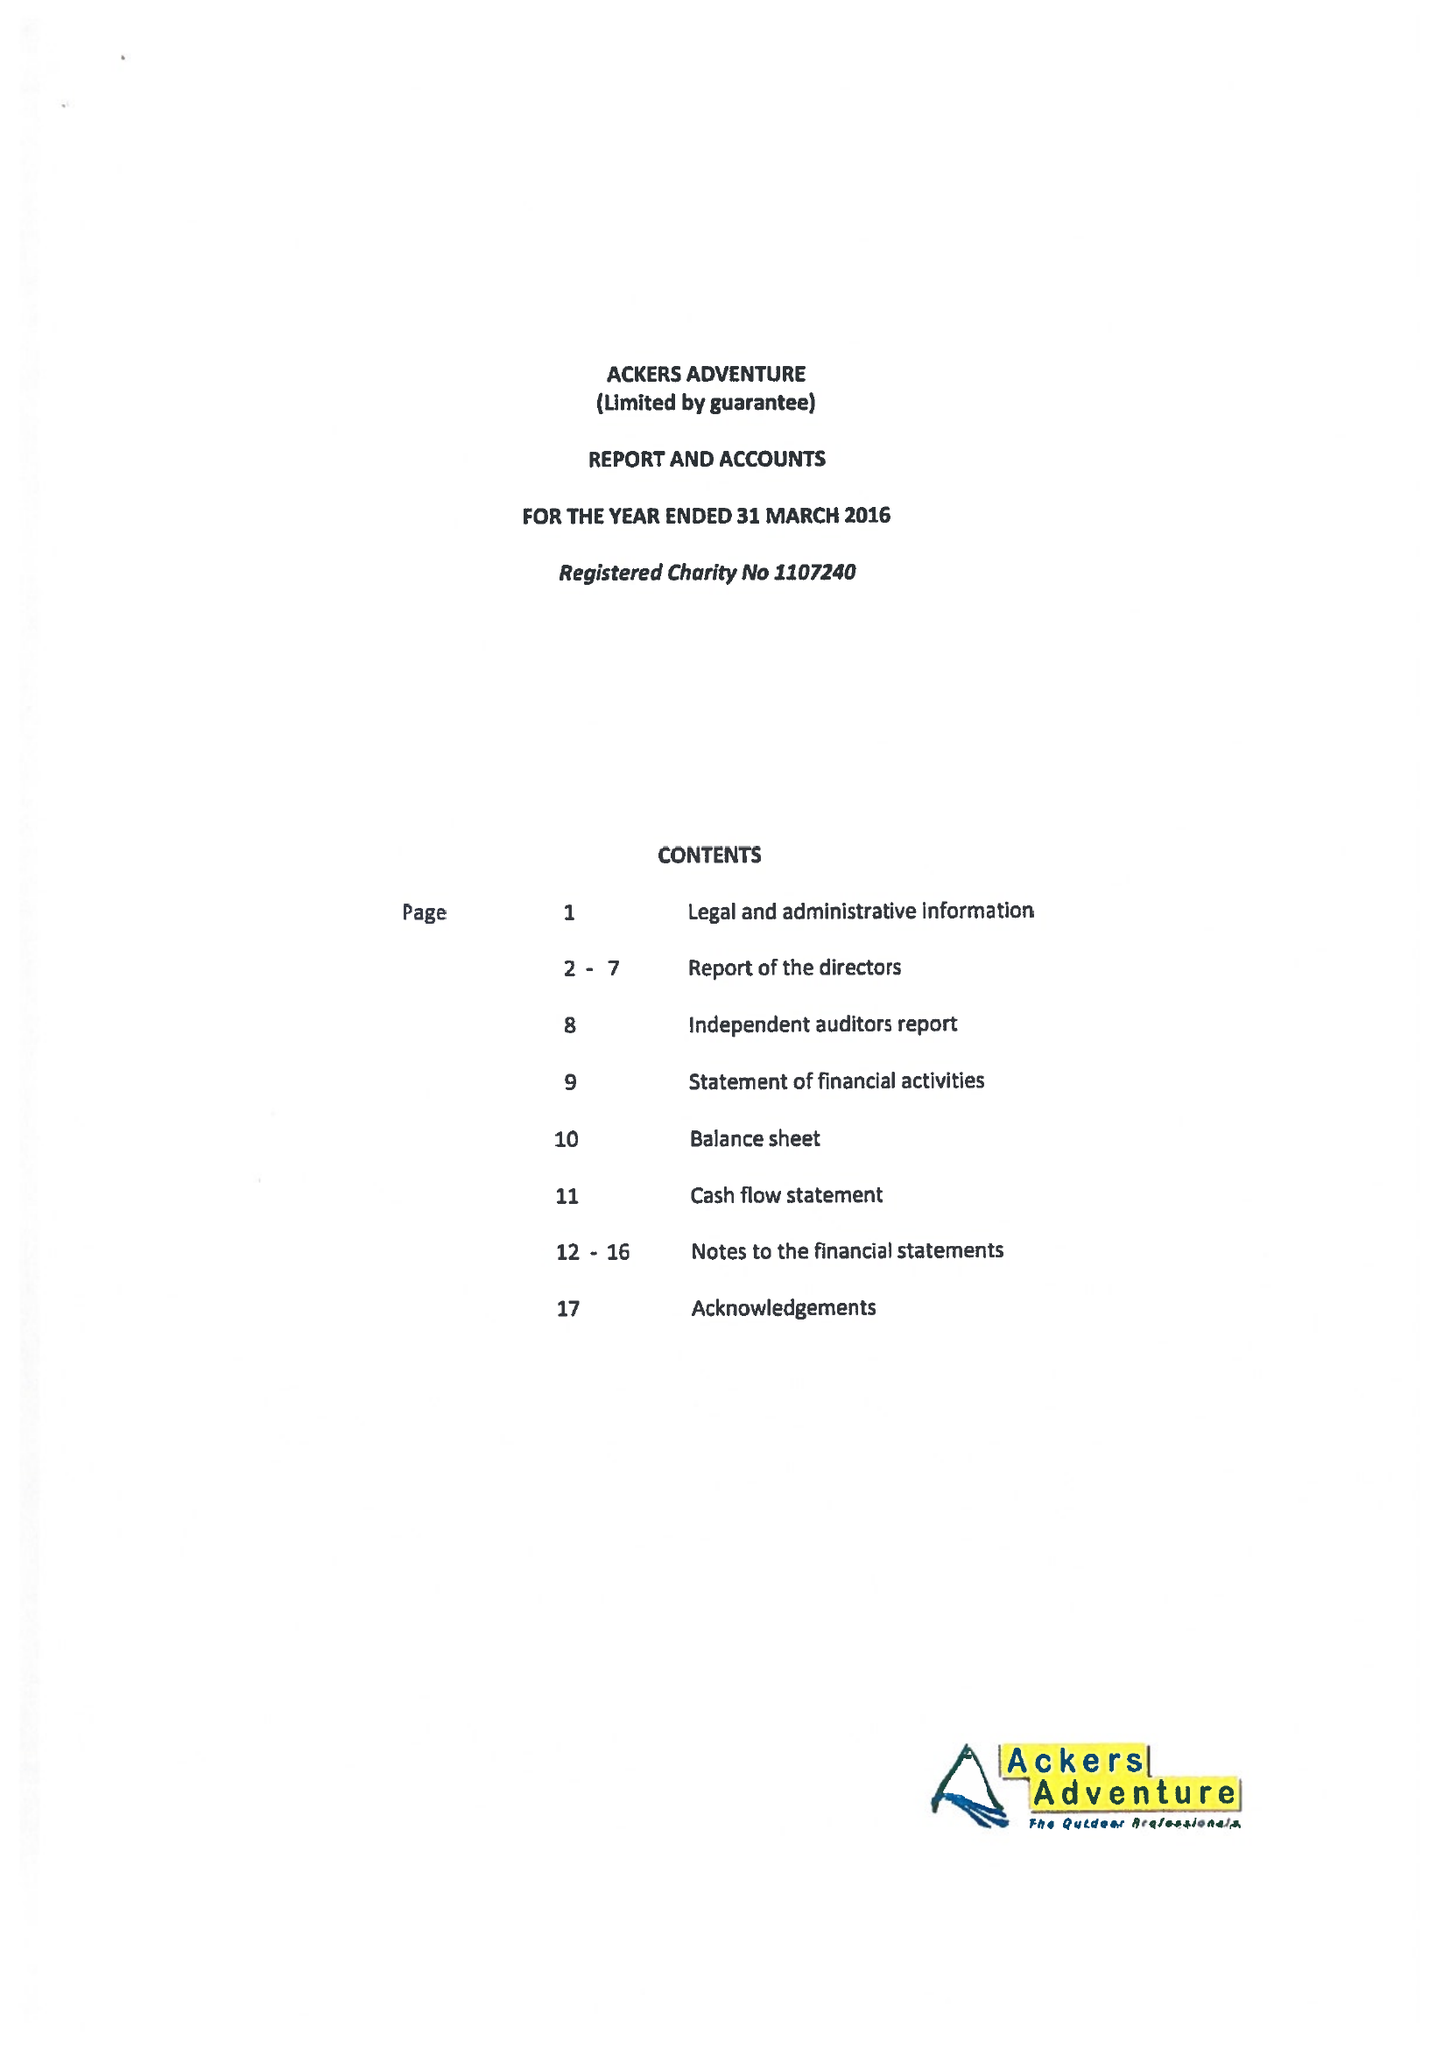What is the value for the address__postcode?
Answer the question using a single word or phrase. B11 2PY 